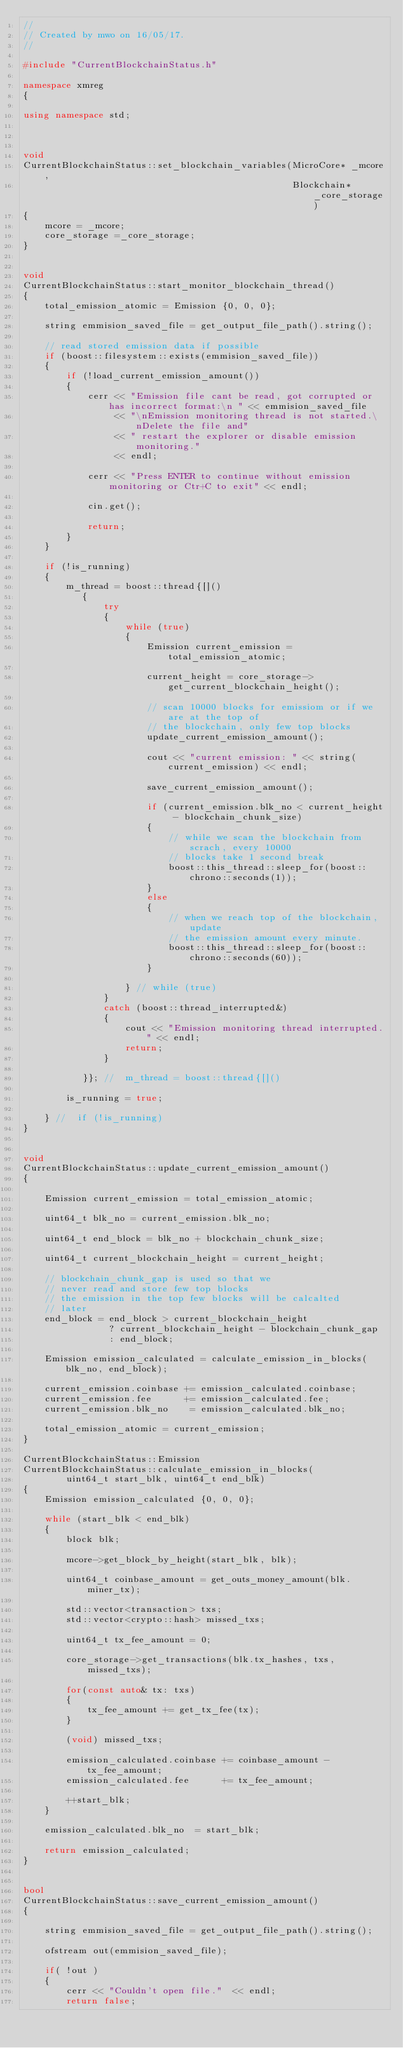Convert code to text. <code><loc_0><loc_0><loc_500><loc_500><_C++_>//
// Created by mwo on 16/05/17.
//

#include "CurrentBlockchainStatus.h"

namespace xmreg
{

using namespace std;



void
CurrentBlockchainStatus::set_blockchain_variables(MicroCore* _mcore,
                                                  Blockchain* _core_storage)
{
    mcore = _mcore;
    core_storage =_core_storage;
}


void
CurrentBlockchainStatus::start_monitor_blockchain_thread()
{
    total_emission_atomic = Emission {0, 0, 0};

    string emmision_saved_file = get_output_file_path().string();

    // read stored emission data if possible
    if (boost::filesystem::exists(emmision_saved_file))
    {
        if (!load_current_emission_amount())
        {
            cerr << "Emission file cant be read, got corrupted or has incorrect format:\n " << emmision_saved_file
                 << "\nEmission monitoring thread is not started.\nDelete the file and"
                 << " restart the explorer or disable emission monitoring."
                 << endl;

            cerr << "Press ENTER to continue without emission monitoring or Ctr+C to exit" << endl;

            cin.get();

            return;
        }
    }

    if (!is_running)
    {
        m_thread = boost::thread{[]()
           {
               try
               {
                   while (true)
                   {
                       Emission current_emission = total_emission_atomic;

                       current_height = core_storage->get_current_blockchain_height();

                       // scan 10000 blocks for emissiom or if we are at the top of
                       // the blockchain, only few top blocks
                       update_current_emission_amount();

                       cout << "current emission: " << string(current_emission) << endl;

                       save_current_emission_amount();

                       if (current_emission.blk_no < current_height - blockchain_chunk_size)
                       {
                           // while we scan the blockchain from scrach, every 10000
                           // blocks take 1 second break
                           boost::this_thread::sleep_for(boost::chrono::seconds(1));
                       }
                       else
                       {
                           // when we reach top of the blockchain, update
                           // the emission amount every minute.
                           boost::this_thread::sleep_for(boost::chrono::seconds(60));
                       }

                   } // while (true)
               }
               catch (boost::thread_interrupted&)
               {
                   cout << "Emission monitoring thread interrupted." << endl;
                   return;
               }

           }}; //  m_thread = boost::thread{[]()

        is_running = true;

    } //  if (!is_running)
}


void
CurrentBlockchainStatus::update_current_emission_amount()
{

    Emission current_emission = total_emission_atomic;

    uint64_t blk_no = current_emission.blk_no;

    uint64_t end_block = blk_no + blockchain_chunk_size;

    uint64_t current_blockchain_height = current_height;

    // blockchain_chunk_gap is used so that we
    // never read and store few top blocks
    // the emission in the top few blocks will be calcalted
    // later
    end_block = end_block > current_blockchain_height
                ? current_blockchain_height - blockchain_chunk_gap
                : end_block;

    Emission emission_calculated = calculate_emission_in_blocks(blk_no, end_block);

    current_emission.coinbase += emission_calculated.coinbase;
    current_emission.fee      += emission_calculated.fee;
    current_emission.blk_no    = emission_calculated.blk_no;

    total_emission_atomic = current_emission;
}

CurrentBlockchainStatus::Emission
CurrentBlockchainStatus::calculate_emission_in_blocks(
        uint64_t start_blk, uint64_t end_blk)
{
    Emission emission_calculated {0, 0, 0};

    while (start_blk < end_blk)
    {
        block blk;

        mcore->get_block_by_height(start_blk, blk);

        uint64_t coinbase_amount = get_outs_money_amount(blk.miner_tx);

        std::vector<transaction> txs;
        std::vector<crypto::hash> missed_txs;

        uint64_t tx_fee_amount = 0;

        core_storage->get_transactions(blk.tx_hashes, txs, missed_txs);

        for(const auto& tx: txs)
        {
            tx_fee_amount += get_tx_fee(tx);
        }

        (void) missed_txs;

        emission_calculated.coinbase += coinbase_amount - tx_fee_amount;
        emission_calculated.fee      += tx_fee_amount;

        ++start_blk;
    }

    emission_calculated.blk_no  = start_blk;

    return emission_calculated;
}


bool
CurrentBlockchainStatus::save_current_emission_amount()
{

    string emmision_saved_file = get_output_file_path().string();

    ofstream out(emmision_saved_file);

    if( !out )
    {
        cerr << "Couldn't open file."  << endl;
        return false;</code> 